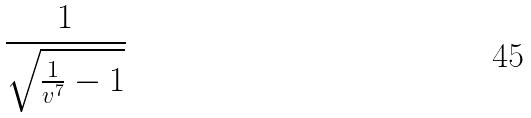<formula> <loc_0><loc_0><loc_500><loc_500>\frac { 1 } { \sqrt { \frac { 1 } { v ^ { 7 } } - 1 } }</formula> 